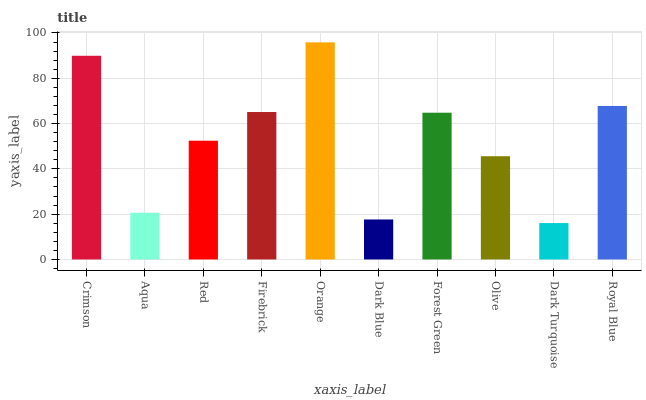Is Dark Turquoise the minimum?
Answer yes or no. Yes. Is Orange the maximum?
Answer yes or no. Yes. Is Aqua the minimum?
Answer yes or no. No. Is Aqua the maximum?
Answer yes or no. No. Is Crimson greater than Aqua?
Answer yes or no. Yes. Is Aqua less than Crimson?
Answer yes or no. Yes. Is Aqua greater than Crimson?
Answer yes or no. No. Is Crimson less than Aqua?
Answer yes or no. No. Is Forest Green the high median?
Answer yes or no. Yes. Is Red the low median?
Answer yes or no. Yes. Is Crimson the high median?
Answer yes or no. No. Is Aqua the low median?
Answer yes or no. No. 